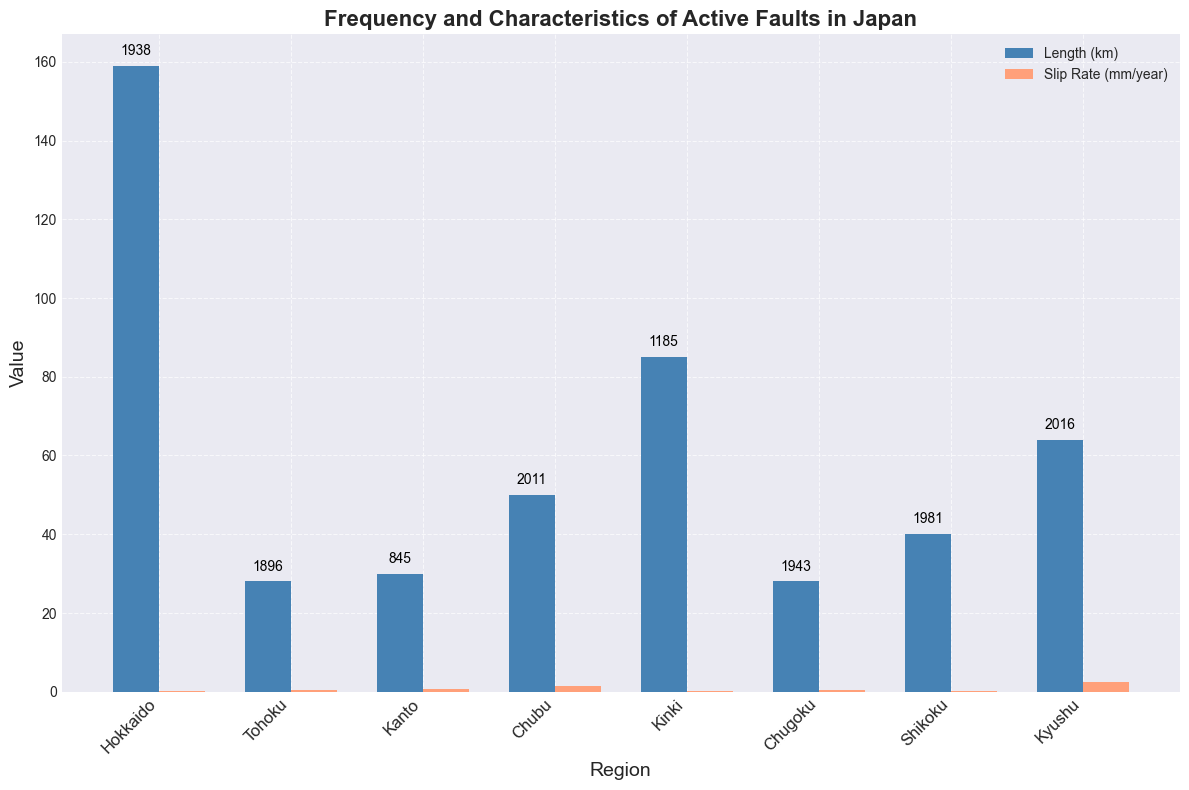How many faults have a length greater than 50 km? To determine the number of faults with a length greater than 50 km, visually inspect the bars representing "Length (km)" for each region and count the ones where the bar height exceeds 50 km. Three regions have fault lengths greater than 50 km: Hokkaido, Kinki, and Kyushu.
Answer: 3 Which region has the highest average slip rate? Look for the highest bar in the "Slip Rate (mm/year)" series. The region with the highest bar is Kyushu. Kyushu has the Futagawa Fault with an average slip rate of 2.5 mm/year.
Answer: Kyushu Compare the length of Hokkaido's fault with its slip rate. Find the bar heights for both "Length (km)" and "Slip Rate (mm/year)" for Hokkaido. The length of Hokkaido's fault (Ishikari-Teichi-Toen Fault Zone) is 159 km, and the slip rate is between 0.2 and 0.3 mm/year, with an average slip rate of 0.25 mm/year.
Answer: Length is 159 km, average slip rate is 0.25 mm/year Which region’s fault has the most recent activity? Find the text annotations above the bars representing the last activity year and identify the most recent year. The fault with the most recent activity is in Kyushu (Futagawa Fault) in 2016.
Answer: Kyushu What is the difference in the length of the longest and shortest faults? Identify the maximum and minimum bar heights in the "Length (km)" series. The longest fault length is 159 km (Hokkaido), and the shortest is 28 km (Tohoku and Chugoku). The difference is calculated as 159 - 28.
Answer: 131 km Which region has a fault with an average slip rate of exactly 0.5 mm/year? Visually inspect the "Slip Rate (mm/year)" bars and find the one with a height of 0.5 mm/year. The region matching this criterion is Kanto (Tachikawa Fault).
Answer: Kanto How many regions have a slip rate below 1.0 mm/year? Count the bars in the "Slip Rate (mm/year)" series that are below the 1.0 mm/year mark. The regions are Hokkaido, Tohoku, Kanto, Kinki, and Shikoku.
Answer: 5 What is the average slip rate across all regions? Add the average slip rates for all regions and divide by the number of regions. The average slip rates are: 0.25, 0.5, 0.75, 1.5, 0.15, 0.55, 0.25, and 2.5. The sum is 6.45, and there are 8 regions, so the average is 6.45 / 8.
Answer: 0.81 mm/year 